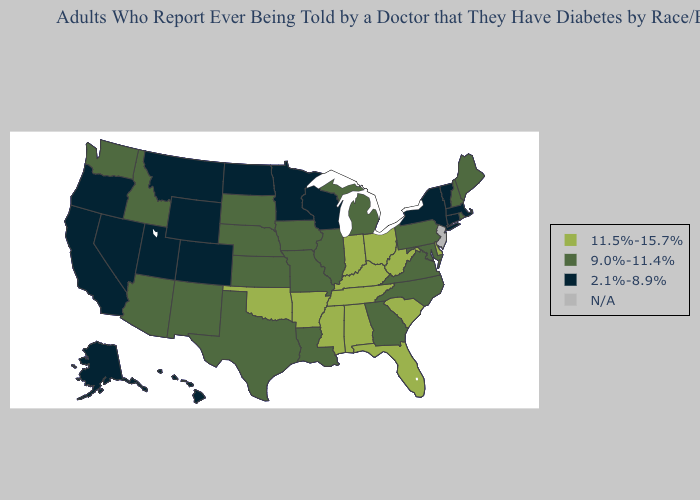Name the states that have a value in the range 11.5%-15.7%?
Answer briefly. Alabama, Arkansas, Delaware, Florida, Indiana, Kentucky, Mississippi, Ohio, Oklahoma, South Carolina, Tennessee, West Virginia. What is the lowest value in the USA?
Give a very brief answer. 2.1%-8.9%. What is the highest value in the USA?
Keep it brief. 11.5%-15.7%. Name the states that have a value in the range 11.5%-15.7%?
Give a very brief answer. Alabama, Arkansas, Delaware, Florida, Indiana, Kentucky, Mississippi, Ohio, Oklahoma, South Carolina, Tennessee, West Virginia. Does Oklahoma have the highest value in the South?
Short answer required. Yes. What is the value of Oregon?
Quick response, please. 2.1%-8.9%. Among the states that border Massachusetts , does Rhode Island have the highest value?
Quick response, please. Yes. Does Nevada have the highest value in the West?
Write a very short answer. No. What is the lowest value in the Northeast?
Give a very brief answer. 2.1%-8.9%. What is the lowest value in states that border Arizona?
Keep it brief. 2.1%-8.9%. Among the states that border Kansas , does Oklahoma have the highest value?
Give a very brief answer. Yes. What is the highest value in the USA?
Concise answer only. 11.5%-15.7%. 